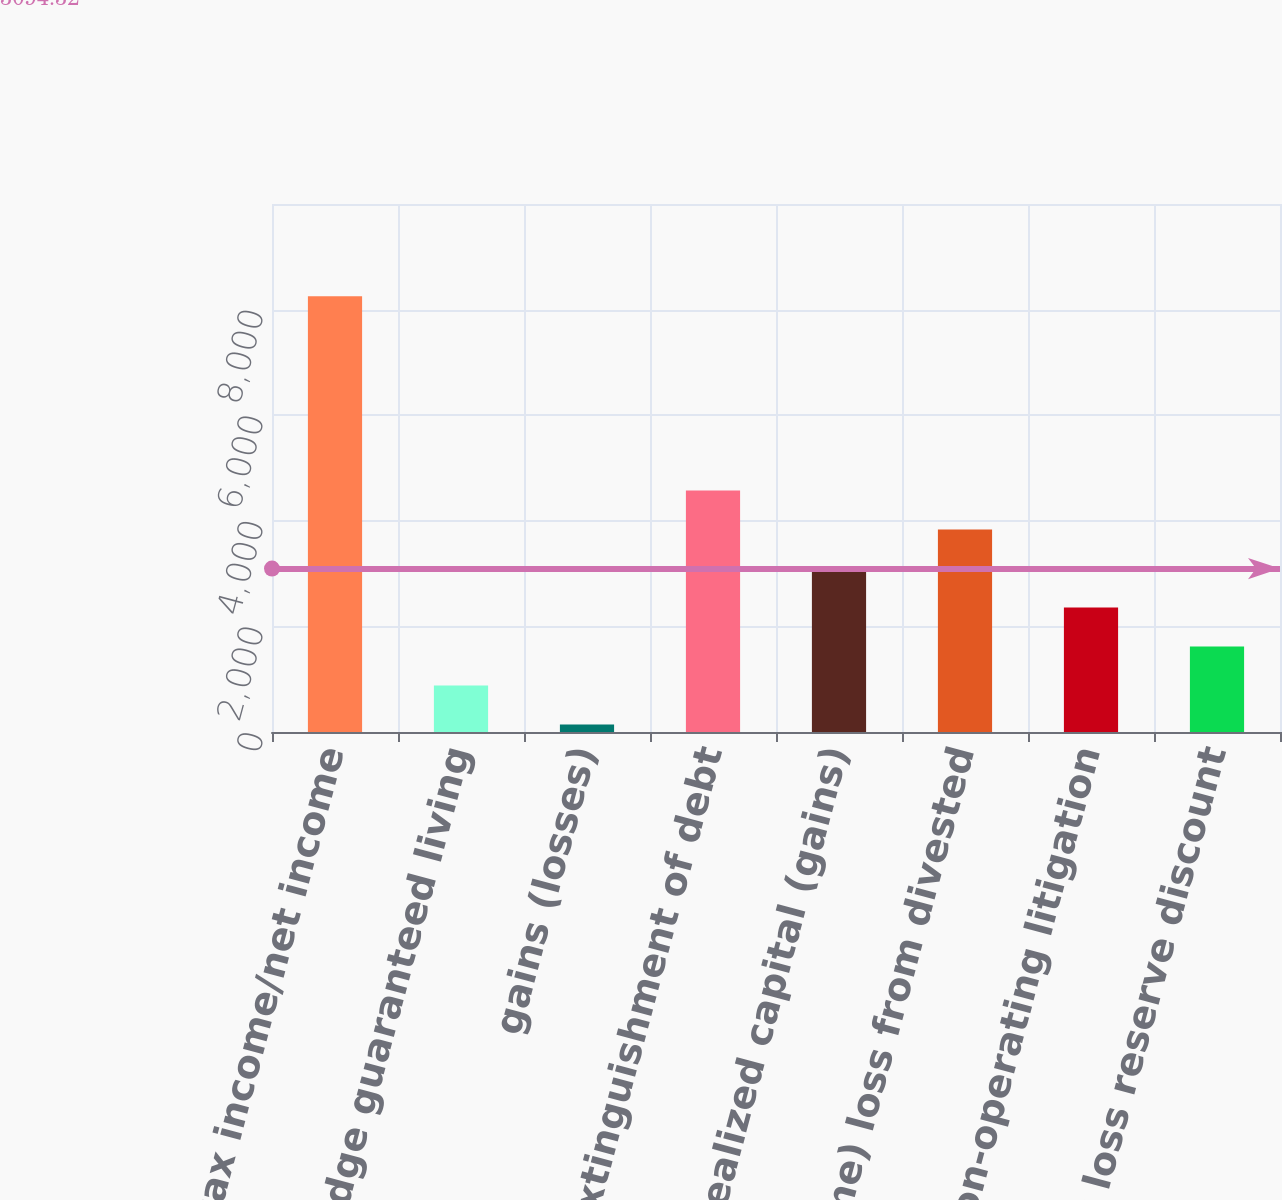<chart> <loc_0><loc_0><loc_500><loc_500><bar_chart><fcel>Pre-tax income/net income<fcel>hedge guaranteed living<fcel>gains (losses)<fcel>Loss on extinguishment of debt<fcel>Net realized capital (gains)<fcel>(Income) loss from divested<fcel>Non-operating litigation<fcel>Net loss reserve discount<nl><fcel>8252.8<fcel>879.8<fcel>141<fcel>4573.8<fcel>3096.2<fcel>3835<fcel>2357.4<fcel>1618.6<nl></chart> 